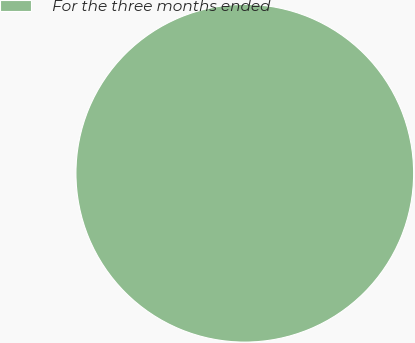Convert chart to OTSL. <chart><loc_0><loc_0><loc_500><loc_500><pie_chart><fcel>For the three months ended<nl><fcel>100.0%<nl></chart> 